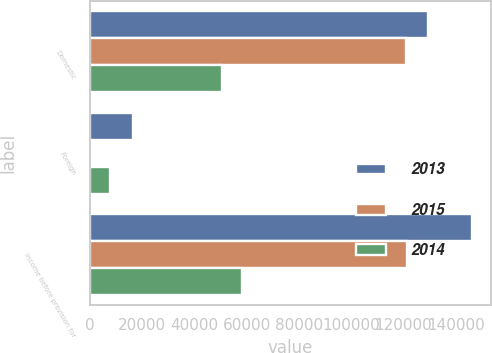Convert chart. <chart><loc_0><loc_0><loc_500><loc_500><stacked_bar_chart><ecel><fcel>Domestic<fcel>Foreign<fcel>Income before provision for<nl><fcel>2013<fcel>129240<fcel>16769<fcel>146009<nl><fcel>2015<fcel>120838<fcel>670<fcel>121508<nl><fcel>2014<fcel>50455<fcel>7820<fcel>58275<nl></chart> 